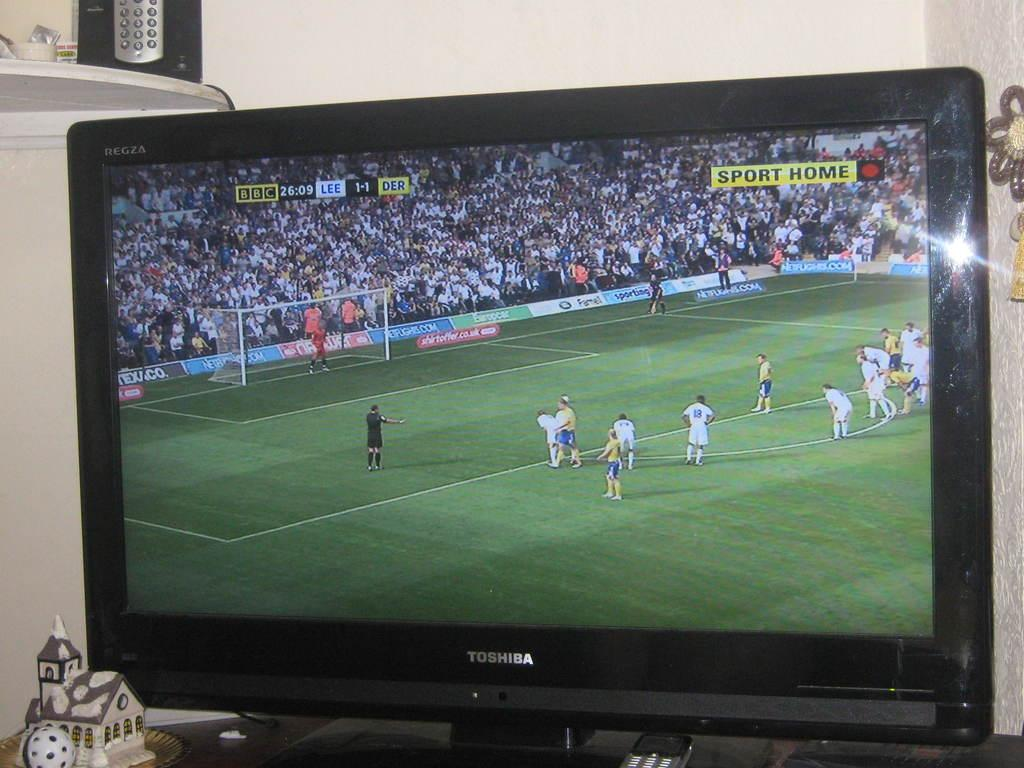<image>
Provide a brief description of the given image. A Toshiba TV showing a sports game and it says Sport Home in the corner. 